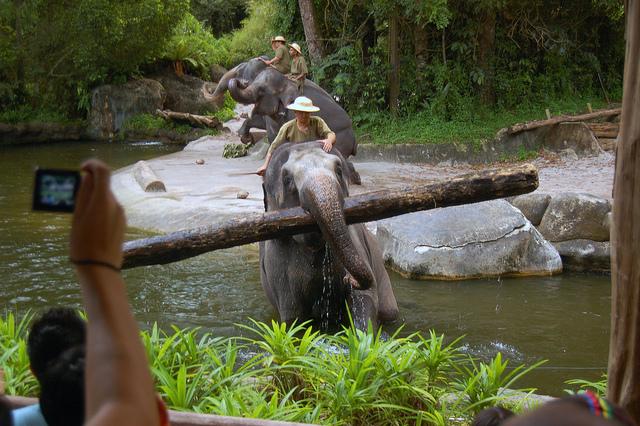What are they riding?
Write a very short answer. Elephants. What type of animal is this?
Give a very brief answer. Elephant. Do the elephants appear to be well behaved?
Concise answer only. Yes. What kind of animals can be seen?
Give a very brief answer. Elephant. What is the elephant holding in its trunk?
Be succinct. Log. 